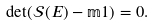<formula> <loc_0><loc_0><loc_500><loc_500>\det ( \mathcal { S } ( E ) - \mathbb { m } { 1 } ) = 0 .</formula> 